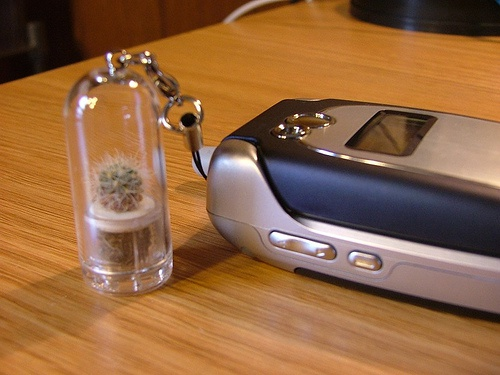Describe the objects in this image and their specific colors. I can see a cell phone in black, gray, darkgray, and navy tones in this image. 